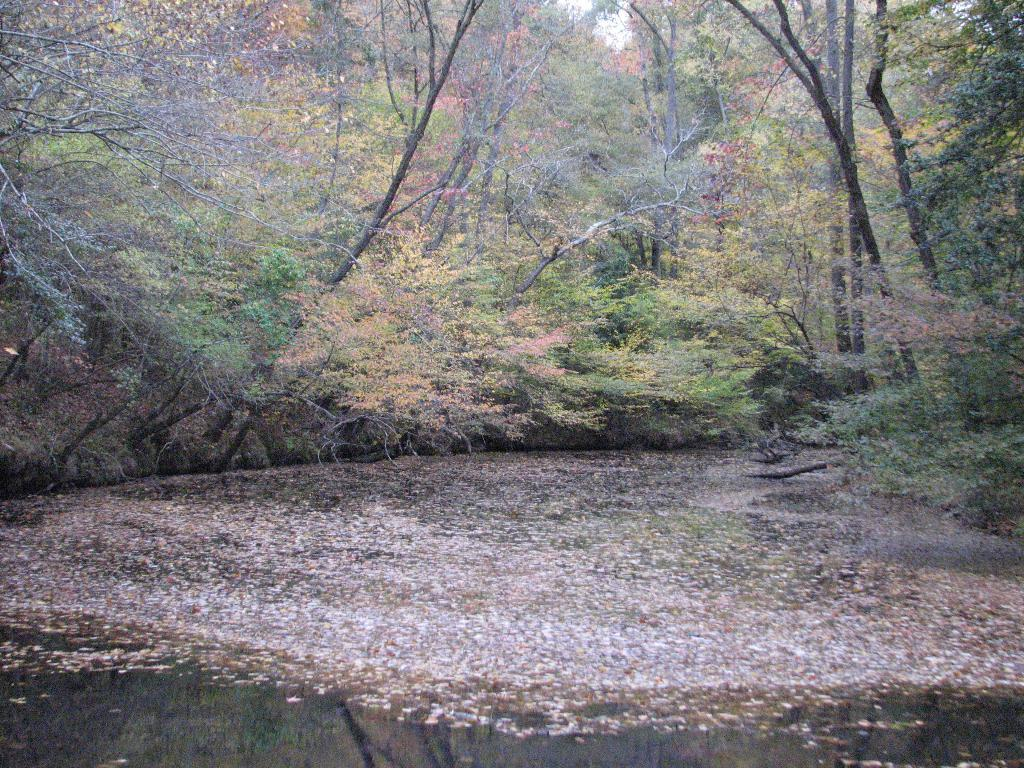What is visible in the image? Water is visible in the image, and dry leaves are floating on the water. What type of vegetation can be seen in the image? There are trees in the image. How does the water guide the leaves in the image? The water does not guide the leaves in the image; the leaves are simply floating on the water's surface. 